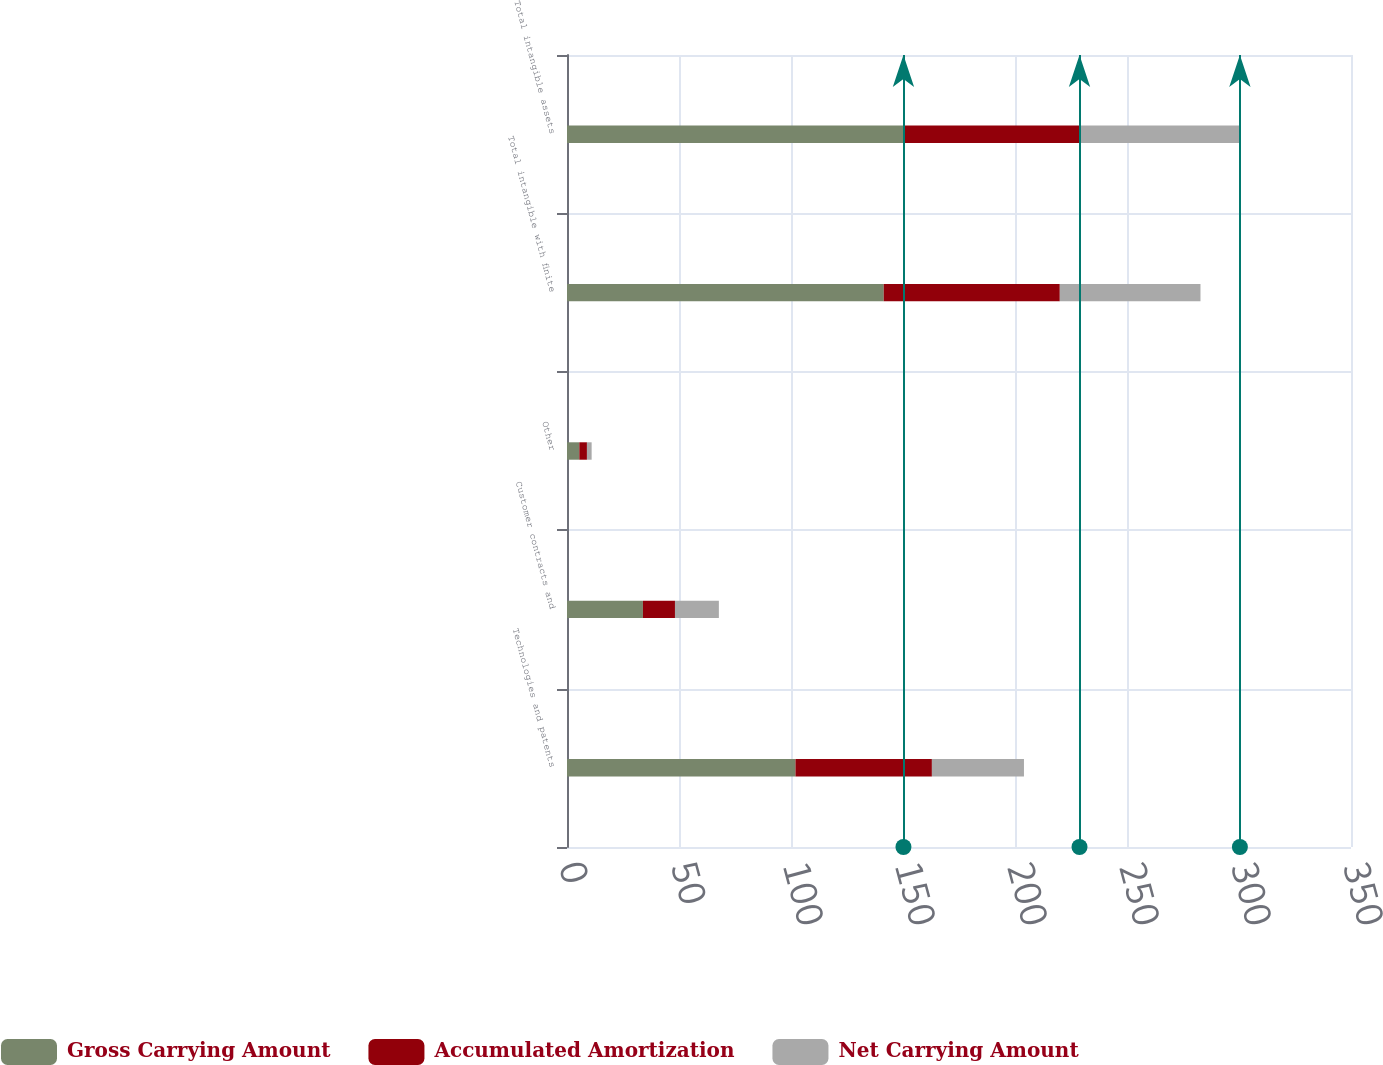<chart> <loc_0><loc_0><loc_500><loc_500><stacked_bar_chart><ecel><fcel>Technologies and patents<fcel>Customer contracts and<fcel>Other<fcel>Total intangible with finite<fcel>Total intangible assets<nl><fcel>Gross Carrying Amount<fcel>102<fcel>33.9<fcel>5.5<fcel>141.4<fcel>150.2<nl><fcel>Accumulated Amortization<fcel>60.9<fcel>14.3<fcel>3.4<fcel>78.6<fcel>78.6<nl><fcel>Net Carrying Amount<fcel>41.1<fcel>19.6<fcel>2.1<fcel>62.8<fcel>71.6<nl></chart> 